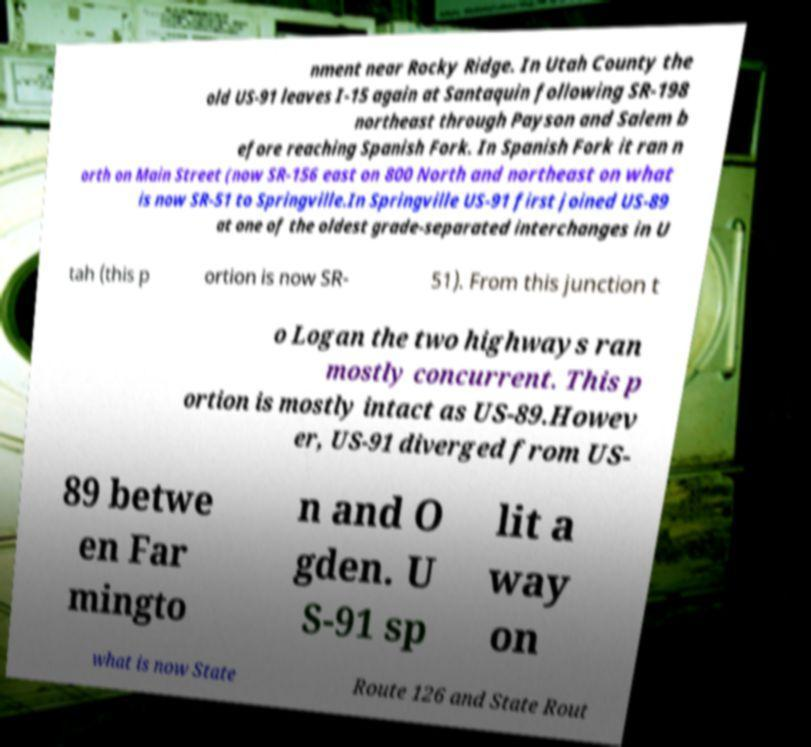For documentation purposes, I need the text within this image transcribed. Could you provide that? nment near Rocky Ridge. In Utah County the old US-91 leaves I-15 again at Santaquin following SR-198 northeast through Payson and Salem b efore reaching Spanish Fork. In Spanish Fork it ran n orth on Main Street (now SR-156 east on 800 North and northeast on what is now SR-51 to Springville.In Springville US-91 first joined US-89 at one of the oldest grade-separated interchanges in U tah (this p ortion is now SR- 51). From this junction t o Logan the two highways ran mostly concurrent. This p ortion is mostly intact as US-89.Howev er, US-91 diverged from US- 89 betwe en Far mingto n and O gden. U S-91 sp lit a way on what is now State Route 126 and State Rout 